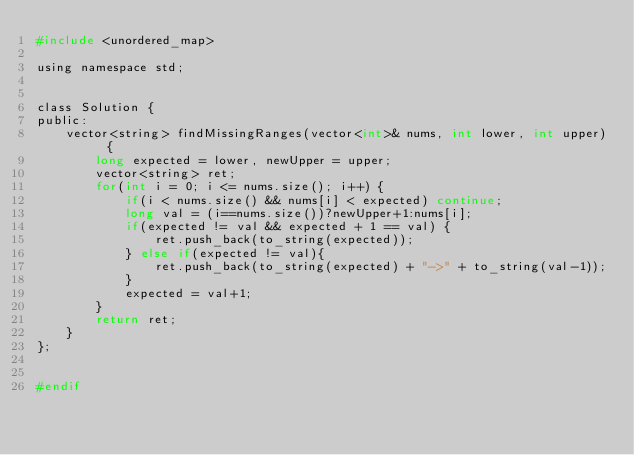Convert code to text. <code><loc_0><loc_0><loc_500><loc_500><_C_>#include <unordered_map>

using namespace std;


class Solution {
public:
    vector<string> findMissingRanges(vector<int>& nums, int lower, int upper) {
        long expected = lower, newUpper = upper;
        vector<string> ret;
        for(int i = 0; i <= nums.size(); i++) {
            if(i < nums.size() && nums[i] < expected) continue;
            long val = (i==nums.size())?newUpper+1:nums[i];
            if(expected != val && expected + 1 == val) {
                ret.push_back(to_string(expected));
            } else if(expected != val){
                ret.push_back(to_string(expected) + "->" + to_string(val-1));
            }
            expected = val+1;
        }
        return ret;
    }
};


#endif
</code> 